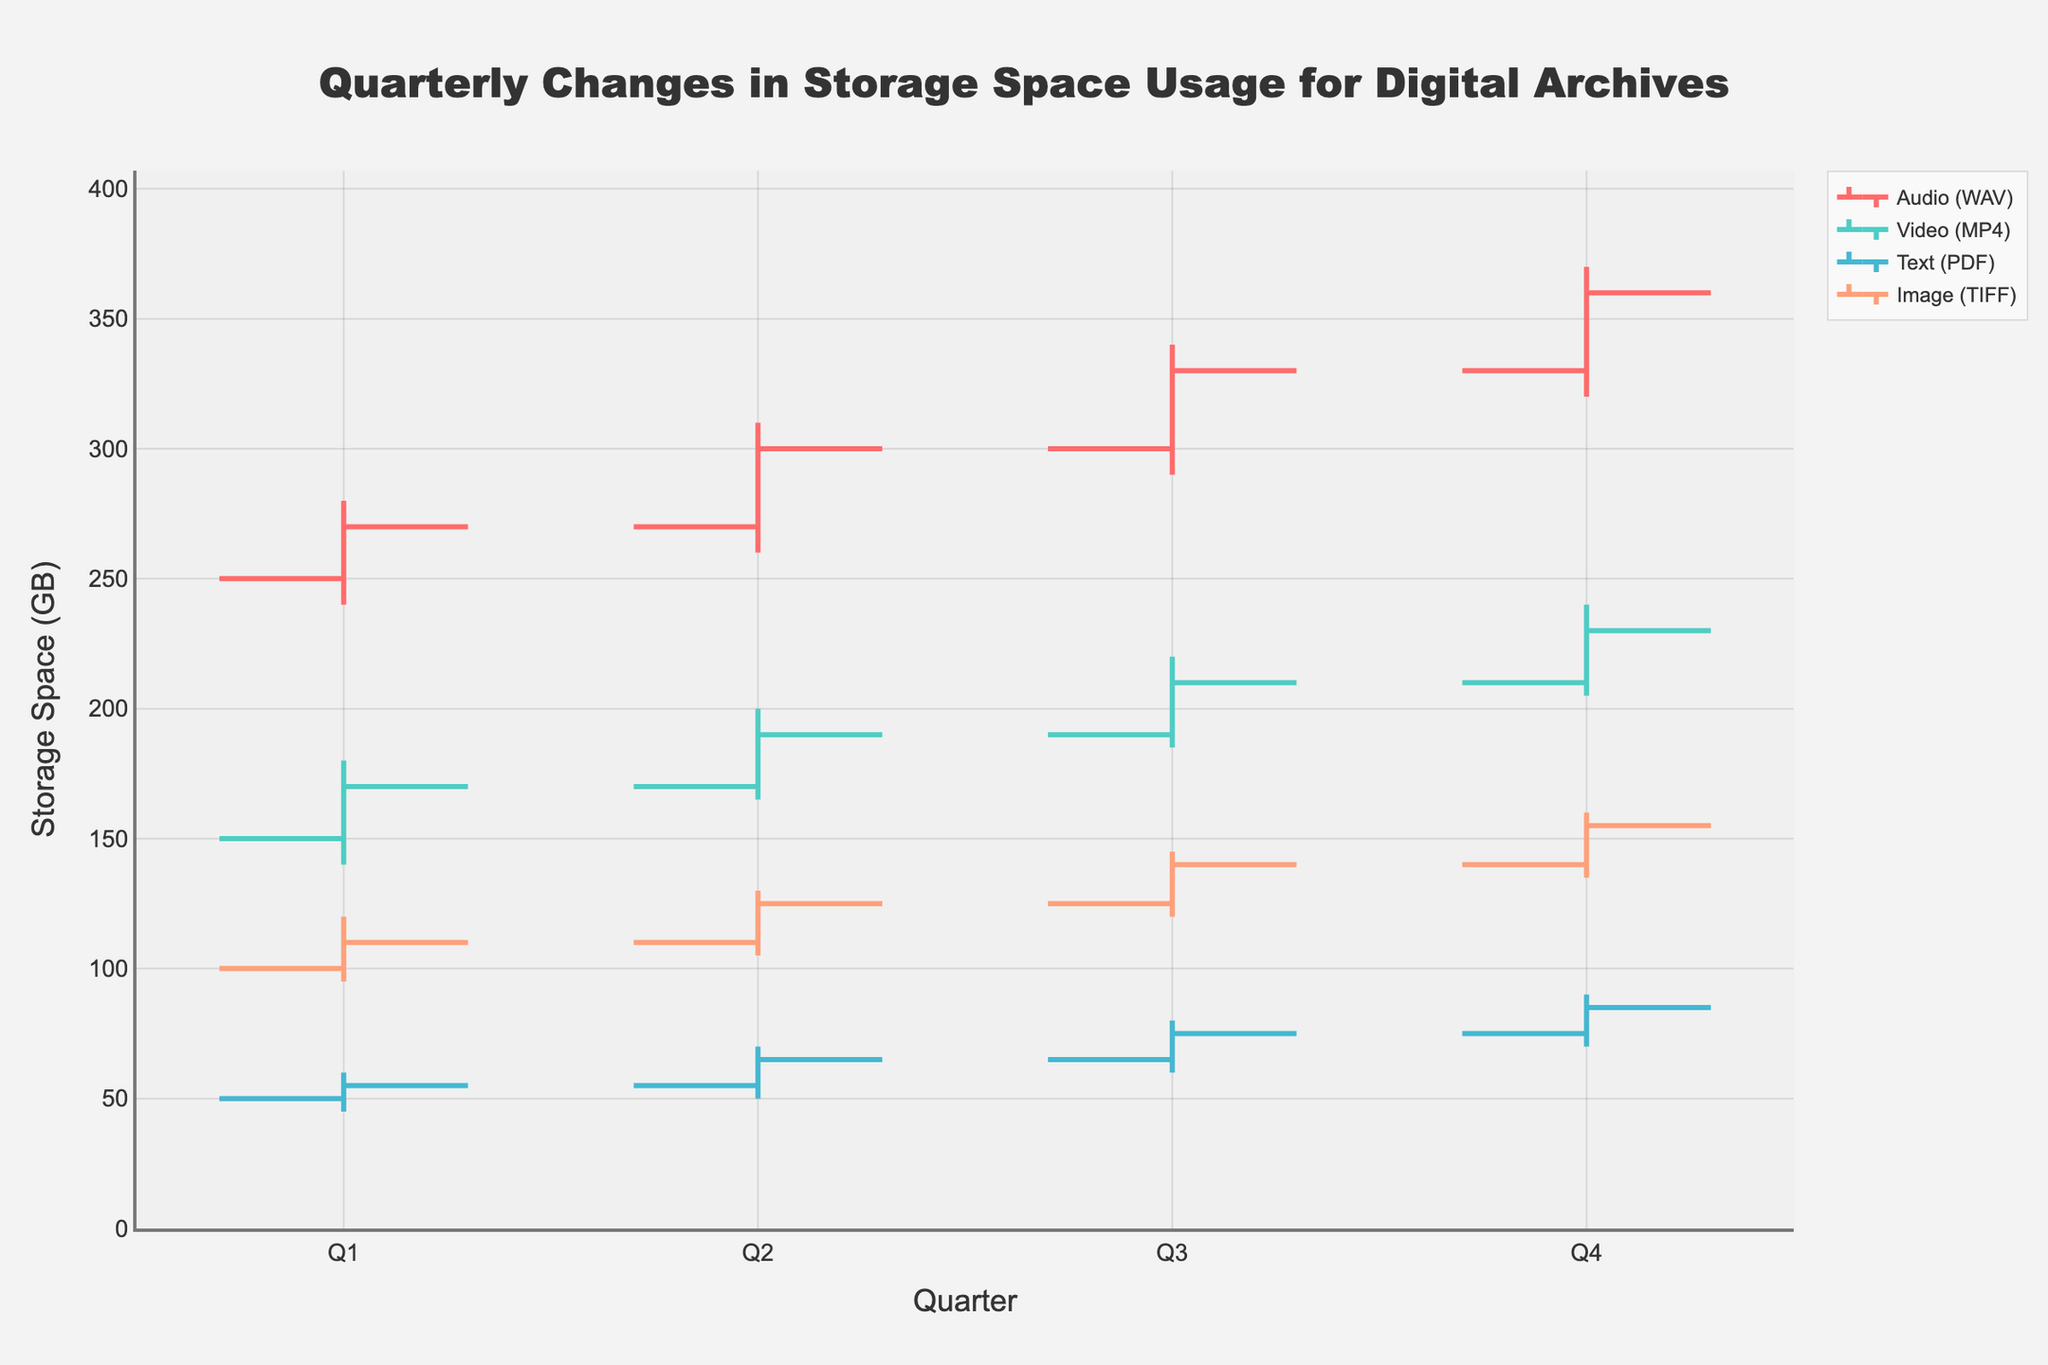What's the title of the figure? The title is located at the top-center of the figure. It reads "Quarterly Changes in Storage Space Usage for Digital Archives".
Answer: Quarterly Changes in Storage Space Usage for Digital Archives What are the axes titles in the figure? The x-axis title is at the bottom of the figure and reads "Quarter". The y-axis title is on the left side of the figure and reads "Storage Space (GB)".
Answer: Quarter and Storage Space (GB) How many quarters are displayed in the figure? The figure displays data along the x-axis for four quarters: Q1, Q2, Q3, and Q4.
Answer: Four What was the highest storage space usage for Audio (WAV) files and in which quarter did it occur? The highest storage space usage for Audio (WAV) files is given by the 'high' value and it is 370 GB, which occurred in Q4.
Answer: 370 GB in Q4 Compare the storage space usage for Video (MP4) and Text (PDF) files in Q1. Which one had higher storage usage and by how much? In Q1, the 'close' value for Video (MP4) files is 170 GB and for Text (PDF) files is 55 GB. Video (MP4) files had a higher storage usage by 170 - 55 = 115 GB.
Answer: Video (MP4) by 115 GB What is the average 'close' value for Image (TIFF) files across all quarters? The 'close' values for Image (TIFF) are: 110, 125, 140, and 155. The average is calculated as (110 + 125 + 140 + 155) / 4 = 530 / 4 = 132.5.
Answer: 132.5 GB Which file type showed the least variation in storage space usage in Q3 and how can you tell? Variation is measured by the difference between the 'high' and 'low' values. In Q3, the variations are: Audio (WAV) = 340-290 = 50, Video (MP4) = 220-185 = 35, Text (PDF) = 80-60 = 20, Image (TIFF) = 145-120 = 25. Text (PDF) has the least variation (20 GB).
Answer: Text (PDF) with 20 GB How did the storage space usage for Text (PDF) files change from Q1 to Q4? The 'close' values for Text (PDF) are compared: Q1 = 55, Q4 = 85. The change is 85 - 55 = 30 GB increase.
Answer: Increased by 30 GB What is the difference between the highest and lowest 'high' values among all file types and quarters? Among all file types and quarters, the highest 'high' value is 370 GB (Audio WAV, Q4) and the lowest 'high' value is 60 GB (Text PDF, Q1). The difference is 370 - 60 = 310 GB.
Answer: 310 GB Which file type showed a steady increase in storage space usage from Q1 to Q4, and how do you determine it from the figure? To determine a steady increase, check the 'close' values for each quarter: Audio (WAV): 270, 300, 330, 360; Video (MP4): 170, 190, 210, 230; Text (PDF): 55, 65, 75, 85; Image (TIFF): 110, 125, 140, 155. All file types showed a steady increase in storage space usage from Q1 to Q4.
Answer: All file types 